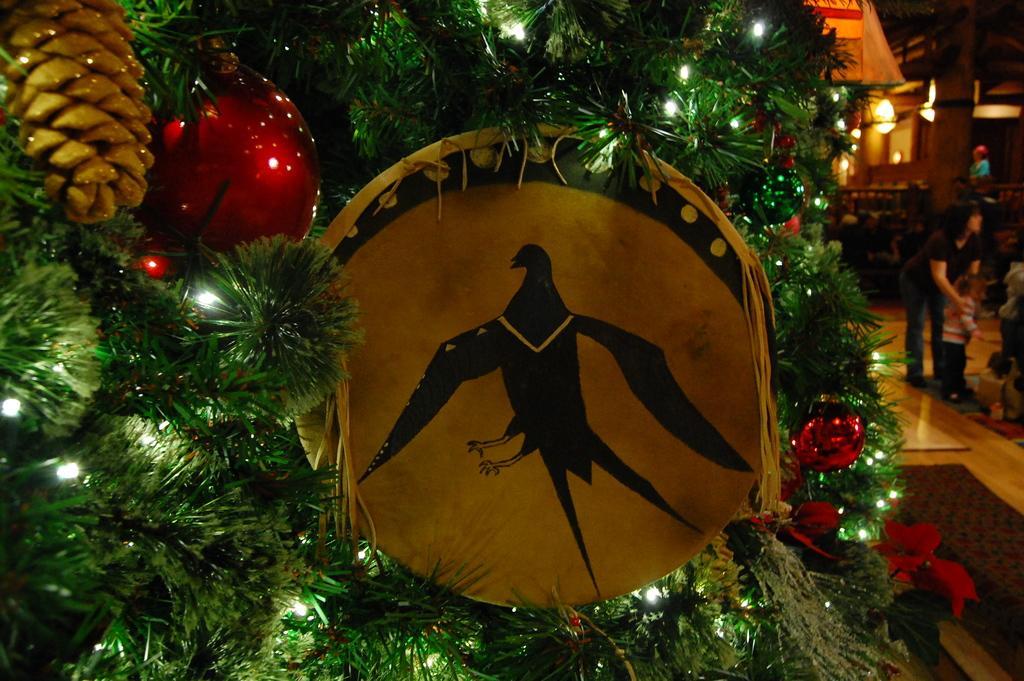Please provide a concise description of this image. In this image we can see yellow color object on which we can see the image of a bird, we can see red color lights are hanged to the Christmas tree. The background of the image is blurred, where we can see a few people on the floor and we can see the ceiling lights. 